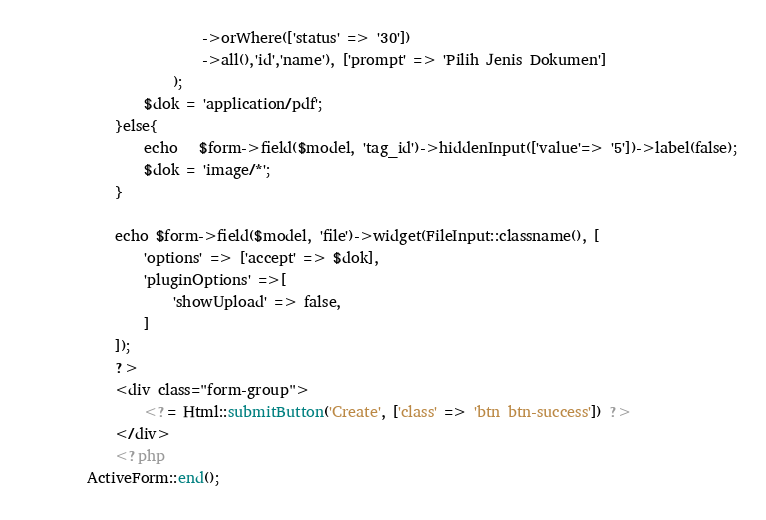<code> <loc_0><loc_0><loc_500><loc_500><_PHP_>                        ->orWhere(['status' => '30'])
                        ->all(),'id','name'), ['prompt' => 'Pilih Jenis Dokumen']
                    );
                $dok = 'application/pdf';
            }else{
                echo   $form->field($model, 'tag_id')->hiddenInput(['value'=> '5'])->label(false);
                $dok = 'image/*';
            }

            echo $form->field($model, 'file')->widget(FileInput::classname(), [
                'options' => ['accept' => $dok],
                'pluginOptions' =>[
                    'showUpload' => false,
                ]
            ]);
            ?>
            <div class="form-group">
                <?= Html::submitButton('Create', ['class' => 'btn btn-success']) ?>
            </div>
            <?php
        ActiveForm::end();</code> 